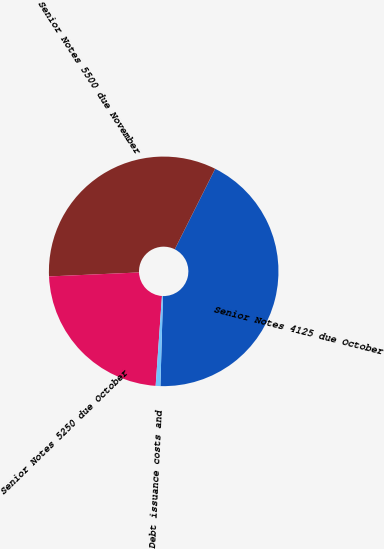Convert chart to OTSL. <chart><loc_0><loc_0><loc_500><loc_500><pie_chart><fcel>Senior Notes 4125 due October<fcel>Senior Notes 5500 due November<fcel>Senior Notes 5250 due October<fcel>Debt issuance costs and<nl><fcel>43.05%<fcel>33.11%<fcel>23.18%<fcel>0.66%<nl></chart> 